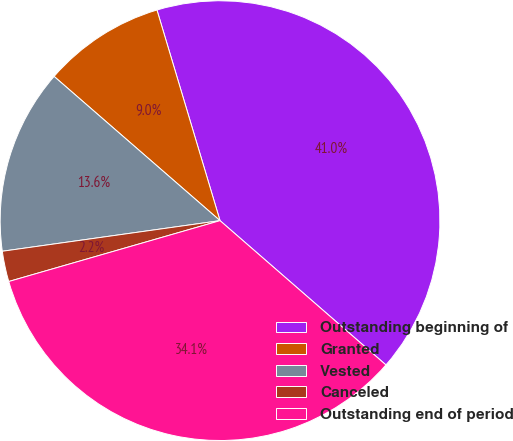Convert chart. <chart><loc_0><loc_0><loc_500><loc_500><pie_chart><fcel>Outstanding beginning of<fcel>Granted<fcel>Vested<fcel>Canceled<fcel>Outstanding end of period<nl><fcel>41.02%<fcel>8.98%<fcel>13.61%<fcel>2.24%<fcel>34.14%<nl></chart> 